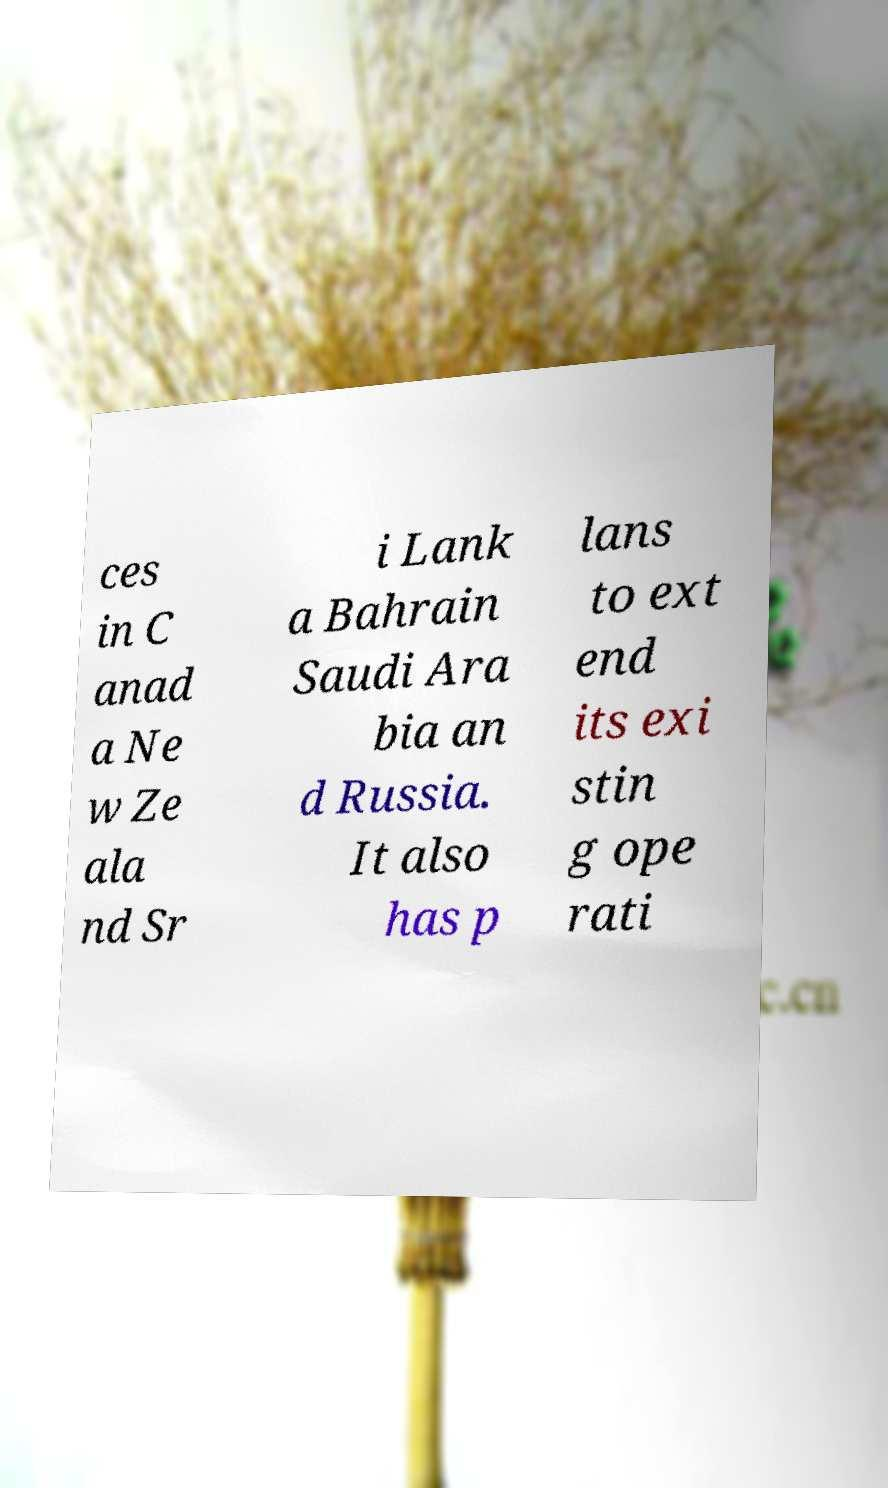Can you read and provide the text displayed in the image?This photo seems to have some interesting text. Can you extract and type it out for me? ces in C anad a Ne w Ze ala nd Sr i Lank a Bahrain Saudi Ara bia an d Russia. It also has p lans to ext end its exi stin g ope rati 